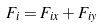<formula> <loc_0><loc_0><loc_500><loc_500>F _ { i } = F _ { i x } + F _ { i y }</formula> 